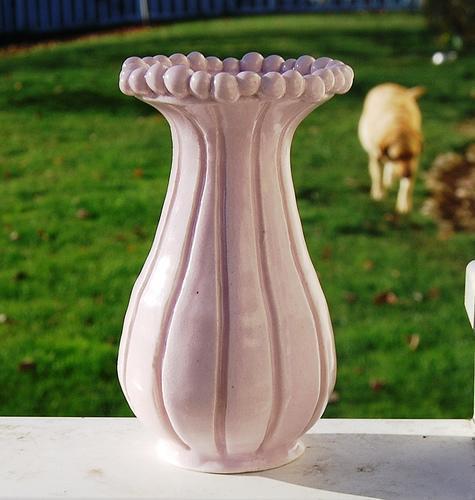How many curved lines are on this item?
Give a very brief answer. 5. How many people are shown?
Give a very brief answer. 0. 